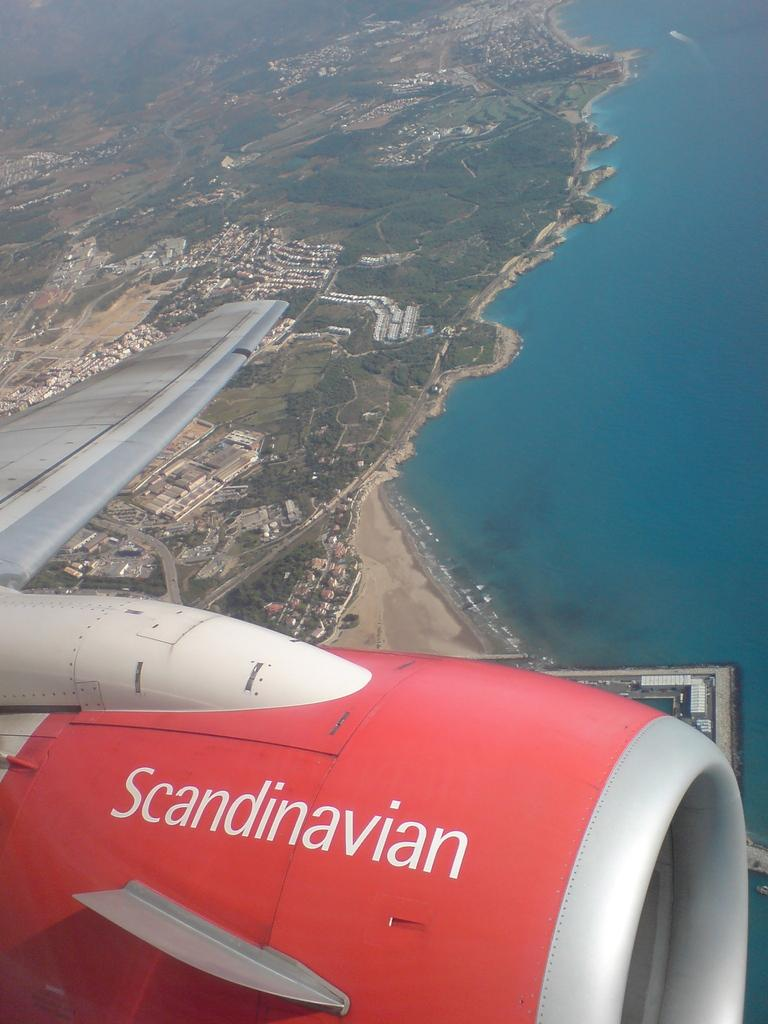What is the main subject of the picture? The main subject of the picture is a plane. What specific parts of the plane can be seen in the image? The plane's turbine engine and wings are visible in the image. What is the plane doing in the picture? The plane is flying in the air. What can be seen in the background of the image? In the background of the image, there is a city, buildings, trees, plants, grass, a beach, and water. Can you tell me how many yaks are visible on the beach in the image? There are no yaks present in the image, and therefore no such animals can be observed on the beach. What type of rake is being used to clean the grass in the image? There is no rake present in the image, and the grass is not being cleaned or maintained in any visible way. 